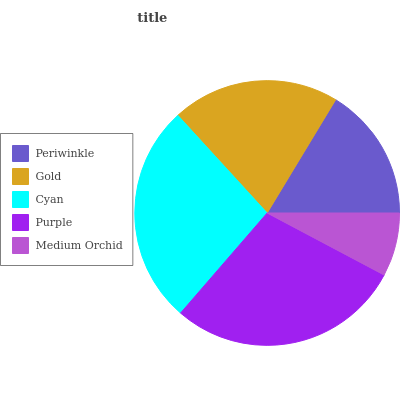Is Medium Orchid the minimum?
Answer yes or no. Yes. Is Purple the maximum?
Answer yes or no. Yes. Is Gold the minimum?
Answer yes or no. No. Is Gold the maximum?
Answer yes or no. No. Is Gold greater than Periwinkle?
Answer yes or no. Yes. Is Periwinkle less than Gold?
Answer yes or no. Yes. Is Periwinkle greater than Gold?
Answer yes or no. No. Is Gold less than Periwinkle?
Answer yes or no. No. Is Gold the high median?
Answer yes or no. Yes. Is Gold the low median?
Answer yes or no. Yes. Is Purple the high median?
Answer yes or no. No. Is Cyan the low median?
Answer yes or no. No. 